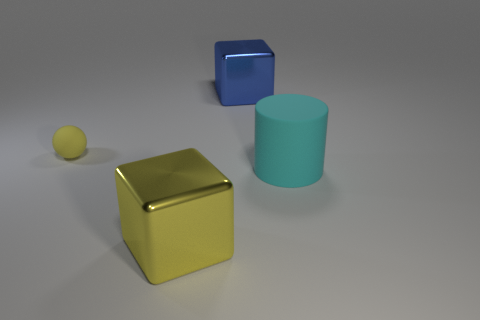Are there any cyan rubber cylinders of the same size as the sphere?
Keep it short and to the point. No. The cyan rubber thing is what shape?
Provide a short and direct response. Cylinder. Is the number of blue cubes that are on the right side of the large matte thing greater than the number of small yellow balls that are right of the large yellow metal thing?
Your answer should be very brief. No. Does the shiny block behind the big yellow thing have the same color as the matte thing in front of the yellow matte ball?
Make the answer very short. No. There is another metal thing that is the same size as the yellow metallic thing; what is its shape?
Your answer should be compact. Cube. Are there any small yellow rubber objects of the same shape as the blue object?
Provide a succinct answer. No. Does the object that is in front of the matte cylinder have the same material as the small yellow sphere behind the big cylinder?
Ensure brevity in your answer.  No. There is a shiny object that is the same color as the tiny rubber sphere; what is its shape?
Provide a short and direct response. Cube. How many big cyan things have the same material as the blue object?
Your response must be concise. 0. The matte ball is what color?
Give a very brief answer. Yellow. 